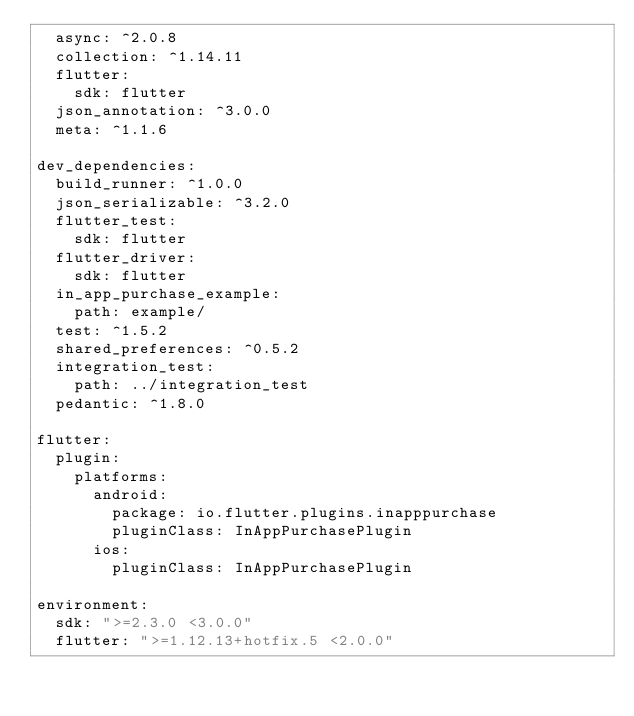Convert code to text. <code><loc_0><loc_0><loc_500><loc_500><_YAML_>  async: ^2.0.8
  collection: ^1.14.11
  flutter:
    sdk: flutter
  json_annotation: ^3.0.0
  meta: ^1.1.6

dev_dependencies:
  build_runner: ^1.0.0
  json_serializable: ^3.2.0
  flutter_test:
    sdk: flutter
  flutter_driver:
    sdk: flutter
  in_app_purchase_example:
    path: example/
  test: ^1.5.2
  shared_preferences: ^0.5.2
  integration_test:
    path: ../integration_test
  pedantic: ^1.8.0

flutter:
  plugin:
    platforms:
      android:
        package: io.flutter.plugins.inapppurchase
        pluginClass: InAppPurchasePlugin
      ios:
        pluginClass: InAppPurchasePlugin

environment:
  sdk: ">=2.3.0 <3.0.0"
  flutter: ">=1.12.13+hotfix.5 <2.0.0"
</code> 